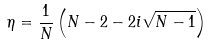Convert formula to latex. <formula><loc_0><loc_0><loc_500><loc_500>\eta = \frac { 1 } { N } \left ( N - 2 - 2 i \sqrt { N - 1 } \right )</formula> 